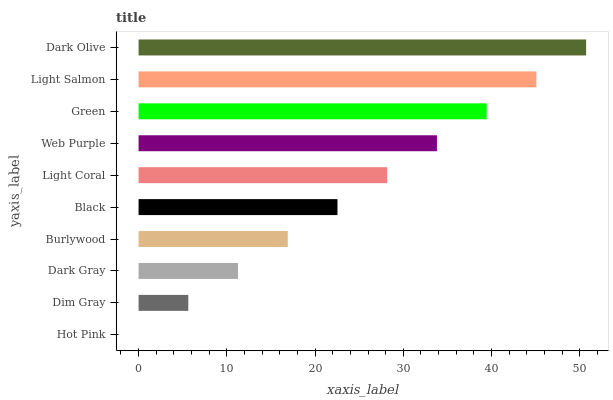Is Hot Pink the minimum?
Answer yes or no. Yes. Is Dark Olive the maximum?
Answer yes or no. Yes. Is Dim Gray the minimum?
Answer yes or no. No. Is Dim Gray the maximum?
Answer yes or no. No. Is Dim Gray greater than Hot Pink?
Answer yes or no. Yes. Is Hot Pink less than Dim Gray?
Answer yes or no. Yes. Is Hot Pink greater than Dim Gray?
Answer yes or no. No. Is Dim Gray less than Hot Pink?
Answer yes or no. No. Is Light Coral the high median?
Answer yes or no. Yes. Is Black the low median?
Answer yes or no. Yes. Is Burlywood the high median?
Answer yes or no. No. Is Dark Olive the low median?
Answer yes or no. No. 